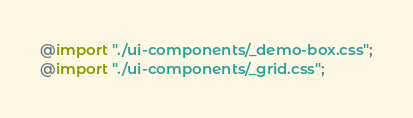<code> <loc_0><loc_0><loc_500><loc_500><_CSS_>@import "./ui-components/_demo-box.css";
@import "./ui-components/_grid.css";
</code> 